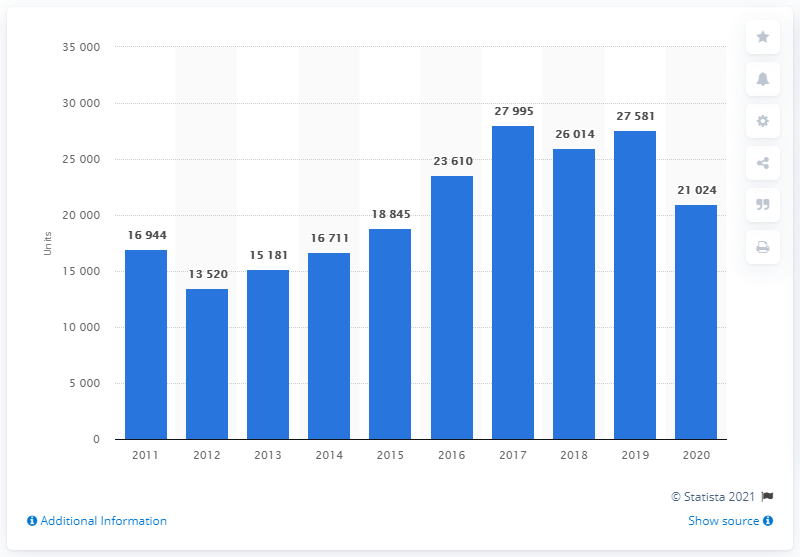Specify some key components in this picture. In 2020, a total of 21,024 Renault cars were registered in Poland. In 2011, a total of 16,944 Renault cars were registered in Poland. 